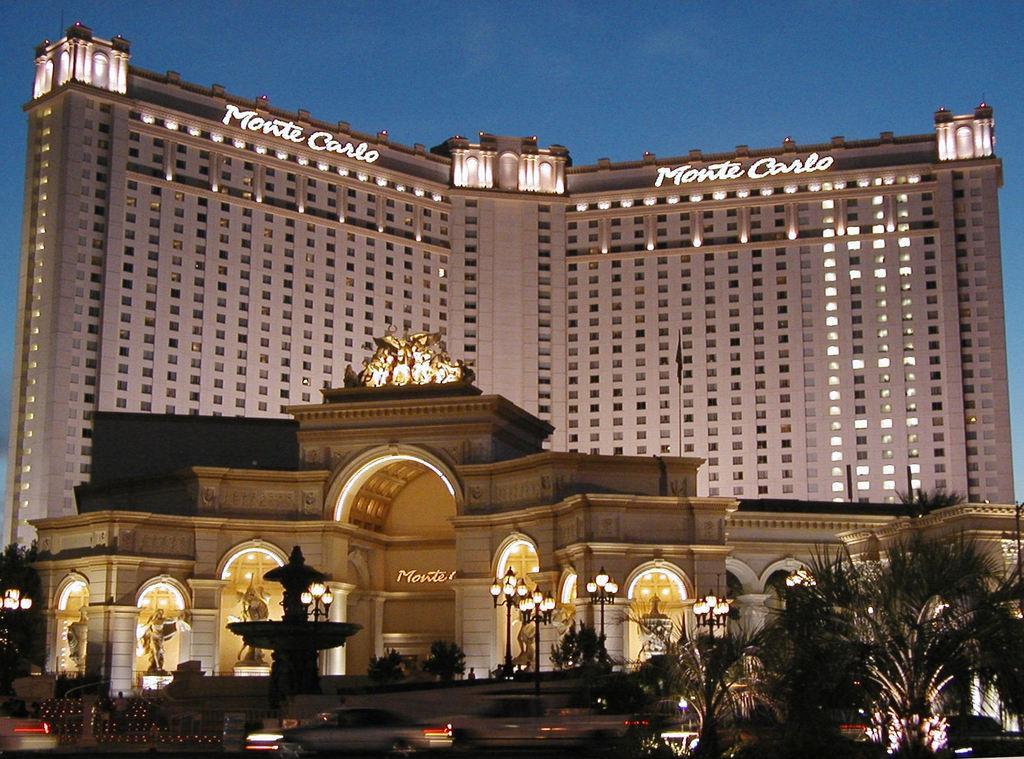Please provide a concise description of this image. In this image I can see few trees, few lights, few vehicles, a fountain, a huge building and few statues in front of the building. In the background I can see the sky. 